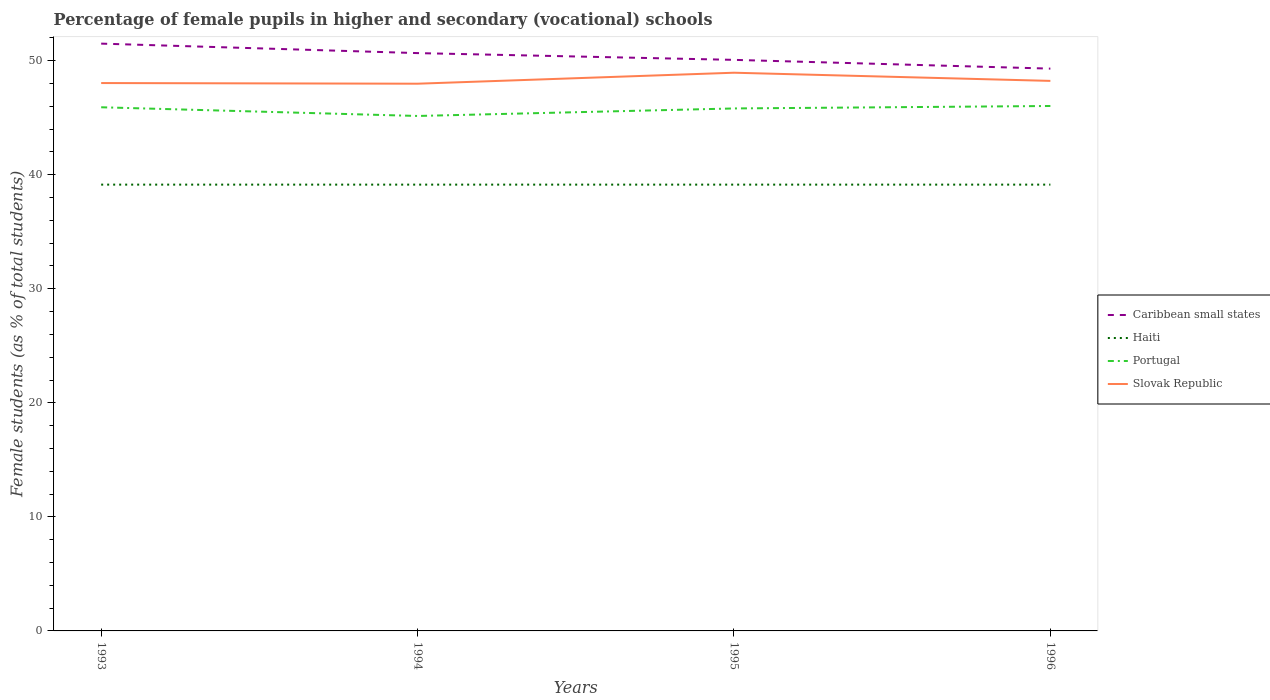Does the line corresponding to Slovak Republic intersect with the line corresponding to Portugal?
Offer a terse response. No. Is the number of lines equal to the number of legend labels?
Provide a succinct answer. Yes. Across all years, what is the maximum percentage of female pupils in higher and secondary schools in Caribbean small states?
Your answer should be compact. 49.3. What is the total percentage of female pupils in higher and secondary schools in Portugal in the graph?
Keep it short and to the point. 0.1. What is the difference between the highest and the second highest percentage of female pupils in higher and secondary schools in Slovak Republic?
Provide a succinct answer. 0.96. What is the difference between the highest and the lowest percentage of female pupils in higher and secondary schools in Slovak Republic?
Your response must be concise. 1. How many years are there in the graph?
Provide a short and direct response. 4. What is the difference between two consecutive major ticks on the Y-axis?
Make the answer very short. 10. Does the graph contain any zero values?
Your answer should be compact. No. Where does the legend appear in the graph?
Your answer should be very brief. Center right. How many legend labels are there?
Provide a succinct answer. 4. What is the title of the graph?
Your answer should be very brief. Percentage of female pupils in higher and secondary (vocational) schools. What is the label or title of the X-axis?
Your answer should be compact. Years. What is the label or title of the Y-axis?
Your response must be concise. Female students (as % of total students). What is the Female students (as % of total students) of Caribbean small states in 1993?
Your response must be concise. 51.49. What is the Female students (as % of total students) of Haiti in 1993?
Provide a succinct answer. 39.13. What is the Female students (as % of total students) of Portugal in 1993?
Offer a terse response. 45.91. What is the Female students (as % of total students) in Slovak Republic in 1993?
Provide a succinct answer. 48.04. What is the Female students (as % of total students) in Caribbean small states in 1994?
Keep it short and to the point. 50.66. What is the Female students (as % of total students) of Haiti in 1994?
Offer a terse response. 39.13. What is the Female students (as % of total students) in Portugal in 1994?
Ensure brevity in your answer.  45.15. What is the Female students (as % of total students) in Slovak Republic in 1994?
Your response must be concise. 47.98. What is the Female students (as % of total students) of Caribbean small states in 1995?
Give a very brief answer. 50.07. What is the Female students (as % of total students) of Haiti in 1995?
Your response must be concise. 39.13. What is the Female students (as % of total students) in Portugal in 1995?
Ensure brevity in your answer.  45.81. What is the Female students (as % of total students) of Slovak Republic in 1995?
Give a very brief answer. 48.94. What is the Female students (as % of total students) of Caribbean small states in 1996?
Your answer should be compact. 49.3. What is the Female students (as % of total students) of Haiti in 1996?
Your answer should be compact. 39.13. What is the Female students (as % of total students) of Portugal in 1996?
Ensure brevity in your answer.  46.03. What is the Female students (as % of total students) of Slovak Republic in 1996?
Provide a succinct answer. 48.23. Across all years, what is the maximum Female students (as % of total students) of Caribbean small states?
Your answer should be compact. 51.49. Across all years, what is the maximum Female students (as % of total students) in Haiti?
Provide a short and direct response. 39.13. Across all years, what is the maximum Female students (as % of total students) in Portugal?
Offer a very short reply. 46.03. Across all years, what is the maximum Female students (as % of total students) in Slovak Republic?
Offer a very short reply. 48.94. Across all years, what is the minimum Female students (as % of total students) of Caribbean small states?
Offer a very short reply. 49.3. Across all years, what is the minimum Female students (as % of total students) of Haiti?
Offer a terse response. 39.13. Across all years, what is the minimum Female students (as % of total students) of Portugal?
Provide a short and direct response. 45.15. Across all years, what is the minimum Female students (as % of total students) in Slovak Republic?
Your answer should be very brief. 47.98. What is the total Female students (as % of total students) in Caribbean small states in the graph?
Make the answer very short. 201.53. What is the total Female students (as % of total students) of Haiti in the graph?
Offer a terse response. 156.52. What is the total Female students (as % of total students) in Portugal in the graph?
Your answer should be very brief. 182.9. What is the total Female students (as % of total students) in Slovak Republic in the graph?
Your answer should be compact. 193.18. What is the difference between the Female students (as % of total students) in Caribbean small states in 1993 and that in 1994?
Your answer should be compact. 0.83. What is the difference between the Female students (as % of total students) of Portugal in 1993 and that in 1994?
Give a very brief answer. 0.76. What is the difference between the Female students (as % of total students) in Slovak Republic in 1993 and that in 1994?
Provide a succinct answer. 0.06. What is the difference between the Female students (as % of total students) in Caribbean small states in 1993 and that in 1995?
Provide a succinct answer. 1.42. What is the difference between the Female students (as % of total students) of Haiti in 1993 and that in 1995?
Your answer should be very brief. 0. What is the difference between the Female students (as % of total students) in Portugal in 1993 and that in 1995?
Your answer should be compact. 0.1. What is the difference between the Female students (as % of total students) in Slovak Republic in 1993 and that in 1995?
Your answer should be very brief. -0.91. What is the difference between the Female students (as % of total students) of Caribbean small states in 1993 and that in 1996?
Keep it short and to the point. 2.19. What is the difference between the Female students (as % of total students) of Portugal in 1993 and that in 1996?
Your answer should be compact. -0.11. What is the difference between the Female students (as % of total students) of Slovak Republic in 1993 and that in 1996?
Your response must be concise. -0.19. What is the difference between the Female students (as % of total students) in Caribbean small states in 1994 and that in 1995?
Offer a terse response. 0.59. What is the difference between the Female students (as % of total students) in Haiti in 1994 and that in 1995?
Provide a succinct answer. 0. What is the difference between the Female students (as % of total students) in Portugal in 1994 and that in 1995?
Give a very brief answer. -0.66. What is the difference between the Female students (as % of total students) of Slovak Republic in 1994 and that in 1995?
Make the answer very short. -0.96. What is the difference between the Female students (as % of total students) in Caribbean small states in 1994 and that in 1996?
Provide a succinct answer. 1.36. What is the difference between the Female students (as % of total students) in Haiti in 1994 and that in 1996?
Give a very brief answer. 0. What is the difference between the Female students (as % of total students) in Portugal in 1994 and that in 1996?
Ensure brevity in your answer.  -0.88. What is the difference between the Female students (as % of total students) of Slovak Republic in 1994 and that in 1996?
Your response must be concise. -0.25. What is the difference between the Female students (as % of total students) in Caribbean small states in 1995 and that in 1996?
Your answer should be very brief. 0.77. What is the difference between the Female students (as % of total students) in Haiti in 1995 and that in 1996?
Ensure brevity in your answer.  0. What is the difference between the Female students (as % of total students) of Portugal in 1995 and that in 1996?
Make the answer very short. -0.22. What is the difference between the Female students (as % of total students) in Slovak Republic in 1995 and that in 1996?
Provide a short and direct response. 0.72. What is the difference between the Female students (as % of total students) of Caribbean small states in 1993 and the Female students (as % of total students) of Haiti in 1994?
Your answer should be very brief. 12.36. What is the difference between the Female students (as % of total students) of Caribbean small states in 1993 and the Female students (as % of total students) of Portugal in 1994?
Give a very brief answer. 6.34. What is the difference between the Female students (as % of total students) of Caribbean small states in 1993 and the Female students (as % of total students) of Slovak Republic in 1994?
Your answer should be compact. 3.51. What is the difference between the Female students (as % of total students) in Haiti in 1993 and the Female students (as % of total students) in Portugal in 1994?
Keep it short and to the point. -6.02. What is the difference between the Female students (as % of total students) of Haiti in 1993 and the Female students (as % of total students) of Slovak Republic in 1994?
Ensure brevity in your answer.  -8.85. What is the difference between the Female students (as % of total students) in Portugal in 1993 and the Female students (as % of total students) in Slovak Republic in 1994?
Your response must be concise. -2.07. What is the difference between the Female students (as % of total students) of Caribbean small states in 1993 and the Female students (as % of total students) of Haiti in 1995?
Provide a succinct answer. 12.36. What is the difference between the Female students (as % of total students) in Caribbean small states in 1993 and the Female students (as % of total students) in Portugal in 1995?
Provide a succinct answer. 5.68. What is the difference between the Female students (as % of total students) of Caribbean small states in 1993 and the Female students (as % of total students) of Slovak Republic in 1995?
Make the answer very short. 2.55. What is the difference between the Female students (as % of total students) of Haiti in 1993 and the Female students (as % of total students) of Portugal in 1995?
Provide a short and direct response. -6.68. What is the difference between the Female students (as % of total students) of Haiti in 1993 and the Female students (as % of total students) of Slovak Republic in 1995?
Provide a succinct answer. -9.81. What is the difference between the Female students (as % of total students) of Portugal in 1993 and the Female students (as % of total students) of Slovak Republic in 1995?
Provide a succinct answer. -3.03. What is the difference between the Female students (as % of total students) of Caribbean small states in 1993 and the Female students (as % of total students) of Haiti in 1996?
Provide a succinct answer. 12.36. What is the difference between the Female students (as % of total students) of Caribbean small states in 1993 and the Female students (as % of total students) of Portugal in 1996?
Provide a short and direct response. 5.47. What is the difference between the Female students (as % of total students) of Caribbean small states in 1993 and the Female students (as % of total students) of Slovak Republic in 1996?
Provide a succinct answer. 3.27. What is the difference between the Female students (as % of total students) of Haiti in 1993 and the Female students (as % of total students) of Portugal in 1996?
Offer a very short reply. -6.9. What is the difference between the Female students (as % of total students) in Haiti in 1993 and the Female students (as % of total students) in Slovak Republic in 1996?
Ensure brevity in your answer.  -9.09. What is the difference between the Female students (as % of total students) of Portugal in 1993 and the Female students (as % of total students) of Slovak Republic in 1996?
Provide a succinct answer. -2.31. What is the difference between the Female students (as % of total students) of Caribbean small states in 1994 and the Female students (as % of total students) of Haiti in 1995?
Your answer should be very brief. 11.53. What is the difference between the Female students (as % of total students) in Caribbean small states in 1994 and the Female students (as % of total students) in Portugal in 1995?
Offer a terse response. 4.85. What is the difference between the Female students (as % of total students) in Caribbean small states in 1994 and the Female students (as % of total students) in Slovak Republic in 1995?
Offer a very short reply. 1.72. What is the difference between the Female students (as % of total students) in Haiti in 1994 and the Female students (as % of total students) in Portugal in 1995?
Keep it short and to the point. -6.68. What is the difference between the Female students (as % of total students) of Haiti in 1994 and the Female students (as % of total students) of Slovak Republic in 1995?
Your answer should be compact. -9.81. What is the difference between the Female students (as % of total students) in Portugal in 1994 and the Female students (as % of total students) in Slovak Republic in 1995?
Offer a very short reply. -3.79. What is the difference between the Female students (as % of total students) in Caribbean small states in 1994 and the Female students (as % of total students) in Haiti in 1996?
Your answer should be compact. 11.53. What is the difference between the Female students (as % of total students) in Caribbean small states in 1994 and the Female students (as % of total students) in Portugal in 1996?
Your answer should be very brief. 4.64. What is the difference between the Female students (as % of total students) of Caribbean small states in 1994 and the Female students (as % of total students) of Slovak Republic in 1996?
Your response must be concise. 2.44. What is the difference between the Female students (as % of total students) of Haiti in 1994 and the Female students (as % of total students) of Portugal in 1996?
Offer a terse response. -6.9. What is the difference between the Female students (as % of total students) of Haiti in 1994 and the Female students (as % of total students) of Slovak Republic in 1996?
Offer a very short reply. -9.09. What is the difference between the Female students (as % of total students) in Portugal in 1994 and the Female students (as % of total students) in Slovak Republic in 1996?
Make the answer very short. -3.08. What is the difference between the Female students (as % of total students) in Caribbean small states in 1995 and the Female students (as % of total students) in Haiti in 1996?
Your answer should be very brief. 10.94. What is the difference between the Female students (as % of total students) of Caribbean small states in 1995 and the Female students (as % of total students) of Portugal in 1996?
Offer a terse response. 4.04. What is the difference between the Female students (as % of total students) in Caribbean small states in 1995 and the Female students (as % of total students) in Slovak Republic in 1996?
Make the answer very short. 1.84. What is the difference between the Female students (as % of total students) of Haiti in 1995 and the Female students (as % of total students) of Portugal in 1996?
Make the answer very short. -6.9. What is the difference between the Female students (as % of total students) in Haiti in 1995 and the Female students (as % of total students) in Slovak Republic in 1996?
Your response must be concise. -9.09. What is the difference between the Female students (as % of total students) of Portugal in 1995 and the Female students (as % of total students) of Slovak Republic in 1996?
Give a very brief answer. -2.42. What is the average Female students (as % of total students) in Caribbean small states per year?
Offer a very short reply. 50.38. What is the average Female students (as % of total students) in Haiti per year?
Offer a very short reply. 39.13. What is the average Female students (as % of total students) in Portugal per year?
Make the answer very short. 45.72. What is the average Female students (as % of total students) in Slovak Republic per year?
Your answer should be very brief. 48.3. In the year 1993, what is the difference between the Female students (as % of total students) of Caribbean small states and Female students (as % of total students) of Haiti?
Make the answer very short. 12.36. In the year 1993, what is the difference between the Female students (as % of total students) in Caribbean small states and Female students (as % of total students) in Portugal?
Your response must be concise. 5.58. In the year 1993, what is the difference between the Female students (as % of total students) of Caribbean small states and Female students (as % of total students) of Slovak Republic?
Make the answer very short. 3.46. In the year 1993, what is the difference between the Female students (as % of total students) of Haiti and Female students (as % of total students) of Portugal?
Offer a very short reply. -6.78. In the year 1993, what is the difference between the Female students (as % of total students) of Haiti and Female students (as % of total students) of Slovak Republic?
Offer a very short reply. -8.91. In the year 1993, what is the difference between the Female students (as % of total students) of Portugal and Female students (as % of total students) of Slovak Republic?
Keep it short and to the point. -2.12. In the year 1994, what is the difference between the Female students (as % of total students) in Caribbean small states and Female students (as % of total students) in Haiti?
Offer a very short reply. 11.53. In the year 1994, what is the difference between the Female students (as % of total students) in Caribbean small states and Female students (as % of total students) in Portugal?
Ensure brevity in your answer.  5.51. In the year 1994, what is the difference between the Female students (as % of total students) of Caribbean small states and Female students (as % of total students) of Slovak Republic?
Your response must be concise. 2.68. In the year 1994, what is the difference between the Female students (as % of total students) of Haiti and Female students (as % of total students) of Portugal?
Your response must be concise. -6.02. In the year 1994, what is the difference between the Female students (as % of total students) in Haiti and Female students (as % of total students) in Slovak Republic?
Give a very brief answer. -8.85. In the year 1994, what is the difference between the Female students (as % of total students) of Portugal and Female students (as % of total students) of Slovak Republic?
Keep it short and to the point. -2.83. In the year 1995, what is the difference between the Female students (as % of total students) in Caribbean small states and Female students (as % of total students) in Haiti?
Give a very brief answer. 10.94. In the year 1995, what is the difference between the Female students (as % of total students) of Caribbean small states and Female students (as % of total students) of Portugal?
Make the answer very short. 4.26. In the year 1995, what is the difference between the Female students (as % of total students) in Caribbean small states and Female students (as % of total students) in Slovak Republic?
Make the answer very short. 1.13. In the year 1995, what is the difference between the Female students (as % of total students) of Haiti and Female students (as % of total students) of Portugal?
Provide a succinct answer. -6.68. In the year 1995, what is the difference between the Female students (as % of total students) of Haiti and Female students (as % of total students) of Slovak Republic?
Ensure brevity in your answer.  -9.81. In the year 1995, what is the difference between the Female students (as % of total students) of Portugal and Female students (as % of total students) of Slovak Republic?
Your answer should be very brief. -3.13. In the year 1996, what is the difference between the Female students (as % of total students) in Caribbean small states and Female students (as % of total students) in Haiti?
Offer a very short reply. 10.17. In the year 1996, what is the difference between the Female students (as % of total students) of Caribbean small states and Female students (as % of total students) of Portugal?
Your answer should be compact. 3.28. In the year 1996, what is the difference between the Female students (as % of total students) in Caribbean small states and Female students (as % of total students) in Slovak Republic?
Your response must be concise. 1.08. In the year 1996, what is the difference between the Female students (as % of total students) in Haiti and Female students (as % of total students) in Portugal?
Your answer should be very brief. -6.9. In the year 1996, what is the difference between the Female students (as % of total students) of Haiti and Female students (as % of total students) of Slovak Republic?
Your answer should be very brief. -9.09. In the year 1996, what is the difference between the Female students (as % of total students) of Portugal and Female students (as % of total students) of Slovak Republic?
Provide a succinct answer. -2.2. What is the ratio of the Female students (as % of total students) in Caribbean small states in 1993 to that in 1994?
Provide a succinct answer. 1.02. What is the ratio of the Female students (as % of total students) in Portugal in 1993 to that in 1994?
Offer a very short reply. 1.02. What is the ratio of the Female students (as % of total students) in Caribbean small states in 1993 to that in 1995?
Make the answer very short. 1.03. What is the ratio of the Female students (as % of total students) in Haiti in 1993 to that in 1995?
Offer a very short reply. 1. What is the ratio of the Female students (as % of total students) in Slovak Republic in 1993 to that in 1995?
Your answer should be compact. 0.98. What is the ratio of the Female students (as % of total students) of Caribbean small states in 1993 to that in 1996?
Keep it short and to the point. 1.04. What is the ratio of the Female students (as % of total students) in Portugal in 1993 to that in 1996?
Keep it short and to the point. 1. What is the ratio of the Female students (as % of total students) of Slovak Republic in 1993 to that in 1996?
Provide a succinct answer. 1. What is the ratio of the Female students (as % of total students) of Caribbean small states in 1994 to that in 1995?
Give a very brief answer. 1.01. What is the ratio of the Female students (as % of total students) of Haiti in 1994 to that in 1995?
Keep it short and to the point. 1. What is the ratio of the Female students (as % of total students) of Portugal in 1994 to that in 1995?
Provide a succinct answer. 0.99. What is the ratio of the Female students (as % of total students) in Slovak Republic in 1994 to that in 1995?
Make the answer very short. 0.98. What is the ratio of the Female students (as % of total students) of Caribbean small states in 1994 to that in 1996?
Offer a very short reply. 1.03. What is the ratio of the Female students (as % of total students) in Slovak Republic in 1994 to that in 1996?
Keep it short and to the point. 0.99. What is the ratio of the Female students (as % of total students) of Caribbean small states in 1995 to that in 1996?
Your answer should be compact. 1.02. What is the ratio of the Female students (as % of total students) of Slovak Republic in 1995 to that in 1996?
Your response must be concise. 1.01. What is the difference between the highest and the second highest Female students (as % of total students) of Caribbean small states?
Provide a succinct answer. 0.83. What is the difference between the highest and the second highest Female students (as % of total students) in Portugal?
Ensure brevity in your answer.  0.11. What is the difference between the highest and the second highest Female students (as % of total students) of Slovak Republic?
Give a very brief answer. 0.72. What is the difference between the highest and the lowest Female students (as % of total students) of Caribbean small states?
Provide a succinct answer. 2.19. What is the difference between the highest and the lowest Female students (as % of total students) of Portugal?
Offer a very short reply. 0.88. What is the difference between the highest and the lowest Female students (as % of total students) in Slovak Republic?
Your answer should be compact. 0.96. 